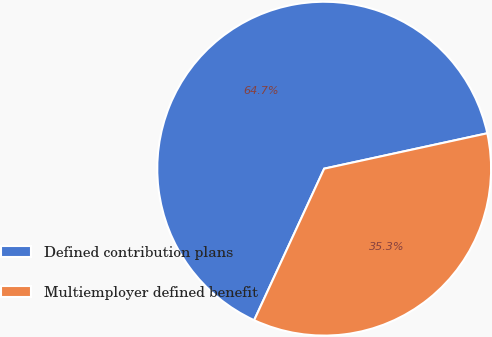Convert chart to OTSL. <chart><loc_0><loc_0><loc_500><loc_500><pie_chart><fcel>Defined contribution plans<fcel>Multiemployer defined benefit<nl><fcel>64.71%<fcel>35.29%<nl></chart> 